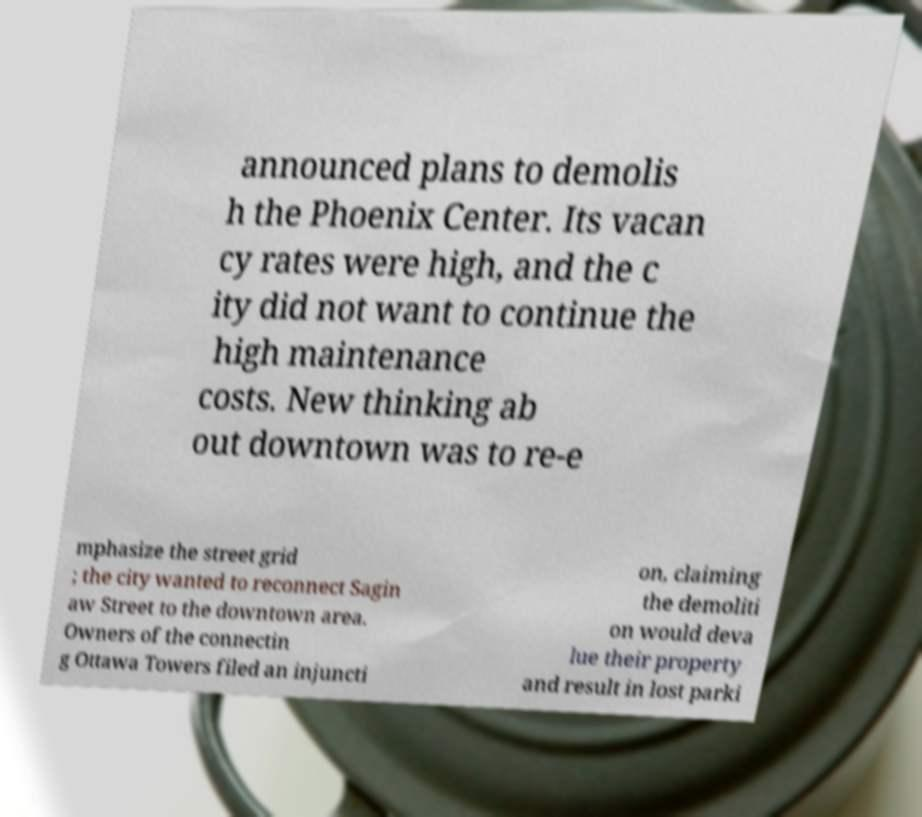Please identify and transcribe the text found in this image. announced plans to demolis h the Phoenix Center. Its vacan cy rates were high, and the c ity did not want to continue the high maintenance costs. New thinking ab out downtown was to re-e mphasize the street grid ; the city wanted to reconnect Sagin aw Street to the downtown area. Owners of the connectin g Ottawa Towers filed an injuncti on, claiming the demoliti on would deva lue their property and result in lost parki 